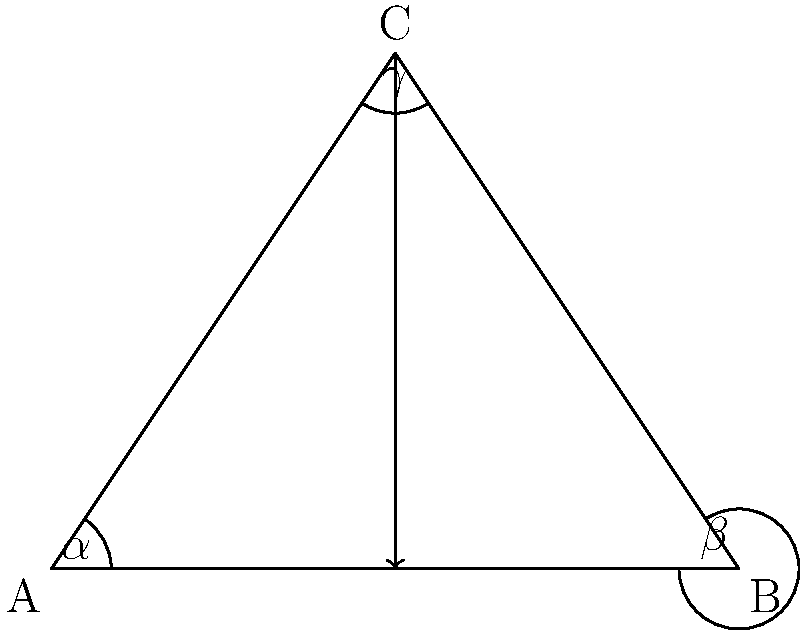In a multi-character narrative, you want to represent three different perspectives using angles in a triangle. If the sum of all angles in the triangle is 180°, and two of the angles (representing two characters' viewpoints) are $\alpha = 60°$ and $\beta = 45°$, what is the measure of the third angle $\gamma$, representing the third character's perspective? To solve this problem, let's follow these steps:

1. Recall the fundamental property of triangles: The sum of all angles in a triangle is always 180°.

2. We are given two angles:
   $\alpha = 60°$
   $\beta = 45°$

3. Let $\gamma$ be the third angle we need to find.

4. We can set up an equation based on the triangle angle sum property:
   $\alpha + \beta + \gamma = 180°$

5. Substitute the known values:
   $60° + 45° + \gamma = 180°$

6. Simplify:
   $105° + \gamma = 180°$

7. Subtract 105° from both sides:
   $\gamma = 180° - 105°$

8. Calculate the result:
   $\gamma = 75°$

Therefore, the measure of the third angle $\gamma$, representing the third character's perspective, is 75°.
Answer: $75°$ 